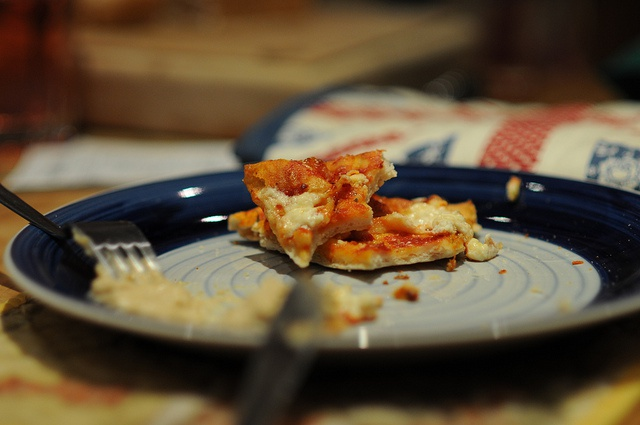Describe the objects in this image and their specific colors. I can see pizza in black, red, maroon, and tan tones, pizza in black, red, brown, and maroon tones, knife in black and gray tones, and fork in black, gray, tan, and darkgray tones in this image. 